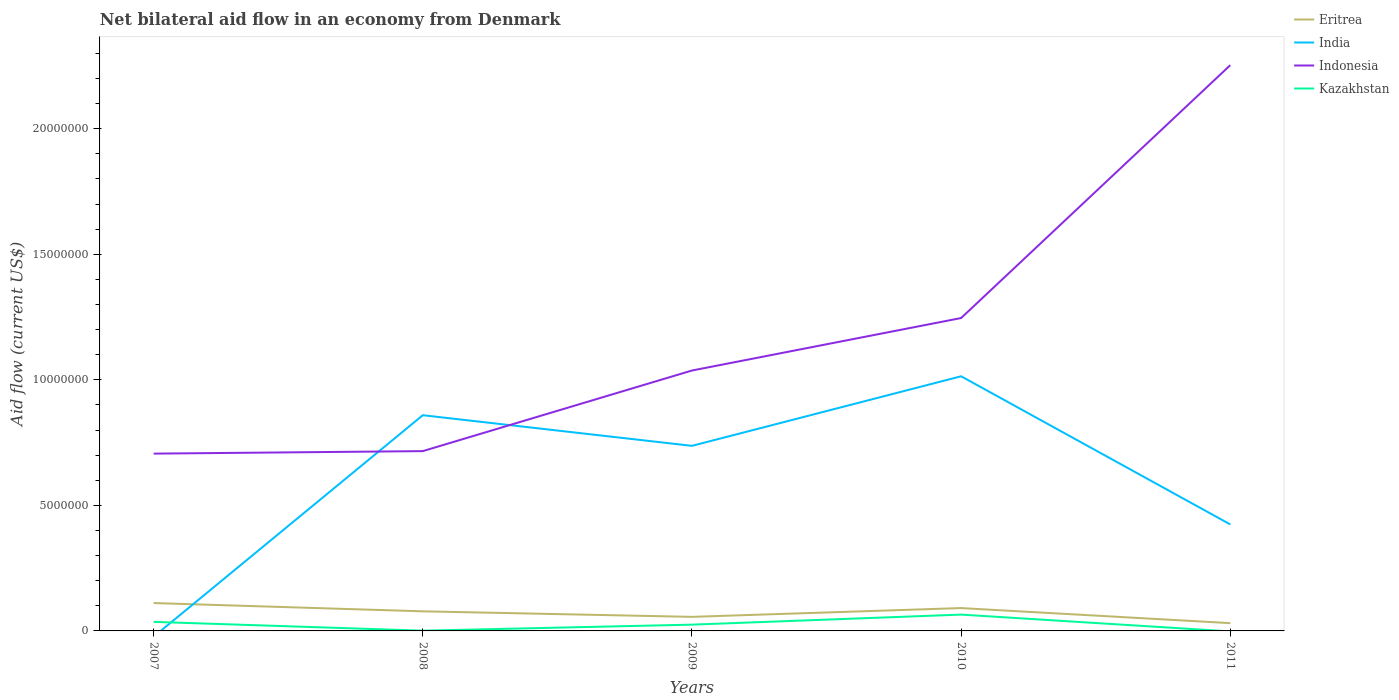How many different coloured lines are there?
Give a very brief answer. 4. Does the line corresponding to Kazakhstan intersect with the line corresponding to India?
Offer a very short reply. Yes. Is the number of lines equal to the number of legend labels?
Give a very brief answer. No. What is the total net bilateral aid flow in Indonesia in the graph?
Provide a succinct answer. -3.21e+06. What is the difference between the highest and the second highest net bilateral aid flow in India?
Provide a short and direct response. 1.01e+07. How many lines are there?
Your answer should be very brief. 4. How many years are there in the graph?
Make the answer very short. 5. Are the values on the major ticks of Y-axis written in scientific E-notation?
Your response must be concise. No. Does the graph contain any zero values?
Your response must be concise. Yes. How many legend labels are there?
Offer a terse response. 4. What is the title of the graph?
Give a very brief answer. Net bilateral aid flow in an economy from Denmark. What is the label or title of the X-axis?
Offer a terse response. Years. What is the Aid flow (current US$) in Eritrea in 2007?
Provide a succinct answer. 1.11e+06. What is the Aid flow (current US$) in Indonesia in 2007?
Provide a short and direct response. 7.06e+06. What is the Aid flow (current US$) in Eritrea in 2008?
Provide a succinct answer. 7.80e+05. What is the Aid flow (current US$) of India in 2008?
Your answer should be compact. 8.59e+06. What is the Aid flow (current US$) in Indonesia in 2008?
Provide a succinct answer. 7.16e+06. What is the Aid flow (current US$) of Kazakhstan in 2008?
Provide a succinct answer. 10000. What is the Aid flow (current US$) in Eritrea in 2009?
Provide a succinct answer. 5.60e+05. What is the Aid flow (current US$) of India in 2009?
Make the answer very short. 7.37e+06. What is the Aid flow (current US$) in Indonesia in 2009?
Offer a terse response. 1.04e+07. What is the Aid flow (current US$) of Kazakhstan in 2009?
Give a very brief answer. 2.50e+05. What is the Aid flow (current US$) of Eritrea in 2010?
Provide a succinct answer. 9.10e+05. What is the Aid flow (current US$) in India in 2010?
Your answer should be compact. 1.01e+07. What is the Aid flow (current US$) of Indonesia in 2010?
Keep it short and to the point. 1.25e+07. What is the Aid flow (current US$) in Kazakhstan in 2010?
Your answer should be very brief. 6.50e+05. What is the Aid flow (current US$) in Eritrea in 2011?
Provide a succinct answer. 3.10e+05. What is the Aid flow (current US$) in India in 2011?
Offer a very short reply. 4.24e+06. What is the Aid flow (current US$) in Indonesia in 2011?
Make the answer very short. 2.25e+07. Across all years, what is the maximum Aid flow (current US$) of Eritrea?
Provide a succinct answer. 1.11e+06. Across all years, what is the maximum Aid flow (current US$) of India?
Your answer should be very brief. 1.01e+07. Across all years, what is the maximum Aid flow (current US$) in Indonesia?
Your answer should be very brief. 2.25e+07. Across all years, what is the maximum Aid flow (current US$) of Kazakhstan?
Your answer should be very brief. 6.50e+05. Across all years, what is the minimum Aid flow (current US$) of Indonesia?
Offer a terse response. 7.06e+06. What is the total Aid flow (current US$) of Eritrea in the graph?
Keep it short and to the point. 3.67e+06. What is the total Aid flow (current US$) of India in the graph?
Make the answer very short. 3.03e+07. What is the total Aid flow (current US$) in Indonesia in the graph?
Offer a very short reply. 5.96e+07. What is the total Aid flow (current US$) in Kazakhstan in the graph?
Provide a short and direct response. 1.27e+06. What is the difference between the Aid flow (current US$) in Eritrea in 2007 and that in 2008?
Give a very brief answer. 3.30e+05. What is the difference between the Aid flow (current US$) in Indonesia in 2007 and that in 2008?
Make the answer very short. -1.00e+05. What is the difference between the Aid flow (current US$) of Kazakhstan in 2007 and that in 2008?
Keep it short and to the point. 3.50e+05. What is the difference between the Aid flow (current US$) in Eritrea in 2007 and that in 2009?
Make the answer very short. 5.50e+05. What is the difference between the Aid flow (current US$) of Indonesia in 2007 and that in 2009?
Offer a terse response. -3.31e+06. What is the difference between the Aid flow (current US$) of Kazakhstan in 2007 and that in 2009?
Make the answer very short. 1.10e+05. What is the difference between the Aid flow (current US$) in Indonesia in 2007 and that in 2010?
Give a very brief answer. -5.40e+06. What is the difference between the Aid flow (current US$) of Indonesia in 2007 and that in 2011?
Provide a short and direct response. -1.55e+07. What is the difference between the Aid flow (current US$) of India in 2008 and that in 2009?
Your answer should be compact. 1.22e+06. What is the difference between the Aid flow (current US$) of Indonesia in 2008 and that in 2009?
Ensure brevity in your answer.  -3.21e+06. What is the difference between the Aid flow (current US$) of Eritrea in 2008 and that in 2010?
Offer a terse response. -1.30e+05. What is the difference between the Aid flow (current US$) of India in 2008 and that in 2010?
Offer a terse response. -1.55e+06. What is the difference between the Aid flow (current US$) in Indonesia in 2008 and that in 2010?
Your answer should be very brief. -5.30e+06. What is the difference between the Aid flow (current US$) in Kazakhstan in 2008 and that in 2010?
Keep it short and to the point. -6.40e+05. What is the difference between the Aid flow (current US$) in India in 2008 and that in 2011?
Your answer should be very brief. 4.35e+06. What is the difference between the Aid flow (current US$) of Indonesia in 2008 and that in 2011?
Offer a very short reply. -1.54e+07. What is the difference between the Aid flow (current US$) of Eritrea in 2009 and that in 2010?
Give a very brief answer. -3.50e+05. What is the difference between the Aid flow (current US$) in India in 2009 and that in 2010?
Ensure brevity in your answer.  -2.77e+06. What is the difference between the Aid flow (current US$) of Indonesia in 2009 and that in 2010?
Give a very brief answer. -2.09e+06. What is the difference between the Aid flow (current US$) of Kazakhstan in 2009 and that in 2010?
Offer a terse response. -4.00e+05. What is the difference between the Aid flow (current US$) of Eritrea in 2009 and that in 2011?
Your response must be concise. 2.50e+05. What is the difference between the Aid flow (current US$) in India in 2009 and that in 2011?
Your answer should be compact. 3.13e+06. What is the difference between the Aid flow (current US$) in Indonesia in 2009 and that in 2011?
Your answer should be compact. -1.22e+07. What is the difference between the Aid flow (current US$) in Eritrea in 2010 and that in 2011?
Keep it short and to the point. 6.00e+05. What is the difference between the Aid flow (current US$) in India in 2010 and that in 2011?
Ensure brevity in your answer.  5.90e+06. What is the difference between the Aid flow (current US$) of Indonesia in 2010 and that in 2011?
Your response must be concise. -1.01e+07. What is the difference between the Aid flow (current US$) of Eritrea in 2007 and the Aid flow (current US$) of India in 2008?
Provide a short and direct response. -7.48e+06. What is the difference between the Aid flow (current US$) of Eritrea in 2007 and the Aid flow (current US$) of Indonesia in 2008?
Keep it short and to the point. -6.05e+06. What is the difference between the Aid flow (current US$) in Eritrea in 2007 and the Aid flow (current US$) in Kazakhstan in 2008?
Your answer should be compact. 1.10e+06. What is the difference between the Aid flow (current US$) of Indonesia in 2007 and the Aid flow (current US$) of Kazakhstan in 2008?
Your answer should be very brief. 7.05e+06. What is the difference between the Aid flow (current US$) in Eritrea in 2007 and the Aid flow (current US$) in India in 2009?
Keep it short and to the point. -6.26e+06. What is the difference between the Aid flow (current US$) in Eritrea in 2007 and the Aid flow (current US$) in Indonesia in 2009?
Your answer should be compact. -9.26e+06. What is the difference between the Aid flow (current US$) in Eritrea in 2007 and the Aid flow (current US$) in Kazakhstan in 2009?
Give a very brief answer. 8.60e+05. What is the difference between the Aid flow (current US$) of Indonesia in 2007 and the Aid flow (current US$) of Kazakhstan in 2009?
Give a very brief answer. 6.81e+06. What is the difference between the Aid flow (current US$) of Eritrea in 2007 and the Aid flow (current US$) of India in 2010?
Ensure brevity in your answer.  -9.03e+06. What is the difference between the Aid flow (current US$) in Eritrea in 2007 and the Aid flow (current US$) in Indonesia in 2010?
Make the answer very short. -1.14e+07. What is the difference between the Aid flow (current US$) in Indonesia in 2007 and the Aid flow (current US$) in Kazakhstan in 2010?
Your answer should be very brief. 6.41e+06. What is the difference between the Aid flow (current US$) in Eritrea in 2007 and the Aid flow (current US$) in India in 2011?
Keep it short and to the point. -3.13e+06. What is the difference between the Aid flow (current US$) of Eritrea in 2007 and the Aid flow (current US$) of Indonesia in 2011?
Ensure brevity in your answer.  -2.14e+07. What is the difference between the Aid flow (current US$) of Eritrea in 2008 and the Aid flow (current US$) of India in 2009?
Give a very brief answer. -6.59e+06. What is the difference between the Aid flow (current US$) of Eritrea in 2008 and the Aid flow (current US$) of Indonesia in 2009?
Keep it short and to the point. -9.59e+06. What is the difference between the Aid flow (current US$) in Eritrea in 2008 and the Aid flow (current US$) in Kazakhstan in 2009?
Make the answer very short. 5.30e+05. What is the difference between the Aid flow (current US$) in India in 2008 and the Aid flow (current US$) in Indonesia in 2009?
Offer a terse response. -1.78e+06. What is the difference between the Aid flow (current US$) of India in 2008 and the Aid flow (current US$) of Kazakhstan in 2009?
Offer a terse response. 8.34e+06. What is the difference between the Aid flow (current US$) in Indonesia in 2008 and the Aid flow (current US$) in Kazakhstan in 2009?
Make the answer very short. 6.91e+06. What is the difference between the Aid flow (current US$) of Eritrea in 2008 and the Aid flow (current US$) of India in 2010?
Offer a terse response. -9.36e+06. What is the difference between the Aid flow (current US$) of Eritrea in 2008 and the Aid flow (current US$) of Indonesia in 2010?
Ensure brevity in your answer.  -1.17e+07. What is the difference between the Aid flow (current US$) of India in 2008 and the Aid flow (current US$) of Indonesia in 2010?
Offer a very short reply. -3.87e+06. What is the difference between the Aid flow (current US$) of India in 2008 and the Aid flow (current US$) of Kazakhstan in 2010?
Keep it short and to the point. 7.94e+06. What is the difference between the Aid flow (current US$) in Indonesia in 2008 and the Aid flow (current US$) in Kazakhstan in 2010?
Give a very brief answer. 6.51e+06. What is the difference between the Aid flow (current US$) in Eritrea in 2008 and the Aid flow (current US$) in India in 2011?
Your answer should be very brief. -3.46e+06. What is the difference between the Aid flow (current US$) in Eritrea in 2008 and the Aid flow (current US$) in Indonesia in 2011?
Provide a short and direct response. -2.18e+07. What is the difference between the Aid flow (current US$) in India in 2008 and the Aid flow (current US$) in Indonesia in 2011?
Offer a very short reply. -1.39e+07. What is the difference between the Aid flow (current US$) of Eritrea in 2009 and the Aid flow (current US$) of India in 2010?
Your answer should be very brief. -9.58e+06. What is the difference between the Aid flow (current US$) of Eritrea in 2009 and the Aid flow (current US$) of Indonesia in 2010?
Ensure brevity in your answer.  -1.19e+07. What is the difference between the Aid flow (current US$) of India in 2009 and the Aid flow (current US$) of Indonesia in 2010?
Offer a terse response. -5.09e+06. What is the difference between the Aid flow (current US$) of India in 2009 and the Aid flow (current US$) of Kazakhstan in 2010?
Provide a succinct answer. 6.72e+06. What is the difference between the Aid flow (current US$) of Indonesia in 2009 and the Aid flow (current US$) of Kazakhstan in 2010?
Provide a short and direct response. 9.72e+06. What is the difference between the Aid flow (current US$) of Eritrea in 2009 and the Aid flow (current US$) of India in 2011?
Your answer should be very brief. -3.68e+06. What is the difference between the Aid flow (current US$) in Eritrea in 2009 and the Aid flow (current US$) in Indonesia in 2011?
Give a very brief answer. -2.20e+07. What is the difference between the Aid flow (current US$) of India in 2009 and the Aid flow (current US$) of Indonesia in 2011?
Ensure brevity in your answer.  -1.52e+07. What is the difference between the Aid flow (current US$) of Eritrea in 2010 and the Aid flow (current US$) of India in 2011?
Offer a terse response. -3.33e+06. What is the difference between the Aid flow (current US$) of Eritrea in 2010 and the Aid flow (current US$) of Indonesia in 2011?
Provide a succinct answer. -2.16e+07. What is the difference between the Aid flow (current US$) of India in 2010 and the Aid flow (current US$) of Indonesia in 2011?
Ensure brevity in your answer.  -1.24e+07. What is the average Aid flow (current US$) in Eritrea per year?
Keep it short and to the point. 7.34e+05. What is the average Aid flow (current US$) in India per year?
Provide a succinct answer. 6.07e+06. What is the average Aid flow (current US$) of Indonesia per year?
Offer a very short reply. 1.19e+07. What is the average Aid flow (current US$) of Kazakhstan per year?
Offer a terse response. 2.54e+05. In the year 2007, what is the difference between the Aid flow (current US$) in Eritrea and Aid flow (current US$) in Indonesia?
Ensure brevity in your answer.  -5.95e+06. In the year 2007, what is the difference between the Aid flow (current US$) in Eritrea and Aid flow (current US$) in Kazakhstan?
Provide a short and direct response. 7.50e+05. In the year 2007, what is the difference between the Aid flow (current US$) in Indonesia and Aid flow (current US$) in Kazakhstan?
Offer a terse response. 6.70e+06. In the year 2008, what is the difference between the Aid flow (current US$) of Eritrea and Aid flow (current US$) of India?
Offer a terse response. -7.81e+06. In the year 2008, what is the difference between the Aid flow (current US$) in Eritrea and Aid flow (current US$) in Indonesia?
Keep it short and to the point. -6.38e+06. In the year 2008, what is the difference between the Aid flow (current US$) in Eritrea and Aid flow (current US$) in Kazakhstan?
Provide a succinct answer. 7.70e+05. In the year 2008, what is the difference between the Aid flow (current US$) in India and Aid flow (current US$) in Indonesia?
Offer a terse response. 1.43e+06. In the year 2008, what is the difference between the Aid flow (current US$) of India and Aid flow (current US$) of Kazakhstan?
Offer a very short reply. 8.58e+06. In the year 2008, what is the difference between the Aid flow (current US$) of Indonesia and Aid flow (current US$) of Kazakhstan?
Make the answer very short. 7.15e+06. In the year 2009, what is the difference between the Aid flow (current US$) in Eritrea and Aid flow (current US$) in India?
Keep it short and to the point. -6.81e+06. In the year 2009, what is the difference between the Aid flow (current US$) in Eritrea and Aid flow (current US$) in Indonesia?
Provide a short and direct response. -9.81e+06. In the year 2009, what is the difference between the Aid flow (current US$) of India and Aid flow (current US$) of Indonesia?
Offer a very short reply. -3.00e+06. In the year 2009, what is the difference between the Aid flow (current US$) of India and Aid flow (current US$) of Kazakhstan?
Provide a succinct answer. 7.12e+06. In the year 2009, what is the difference between the Aid flow (current US$) of Indonesia and Aid flow (current US$) of Kazakhstan?
Offer a terse response. 1.01e+07. In the year 2010, what is the difference between the Aid flow (current US$) in Eritrea and Aid flow (current US$) in India?
Ensure brevity in your answer.  -9.23e+06. In the year 2010, what is the difference between the Aid flow (current US$) of Eritrea and Aid flow (current US$) of Indonesia?
Provide a succinct answer. -1.16e+07. In the year 2010, what is the difference between the Aid flow (current US$) of India and Aid flow (current US$) of Indonesia?
Offer a terse response. -2.32e+06. In the year 2010, what is the difference between the Aid flow (current US$) in India and Aid flow (current US$) in Kazakhstan?
Your answer should be compact. 9.49e+06. In the year 2010, what is the difference between the Aid flow (current US$) in Indonesia and Aid flow (current US$) in Kazakhstan?
Offer a terse response. 1.18e+07. In the year 2011, what is the difference between the Aid flow (current US$) in Eritrea and Aid flow (current US$) in India?
Provide a succinct answer. -3.93e+06. In the year 2011, what is the difference between the Aid flow (current US$) of Eritrea and Aid flow (current US$) of Indonesia?
Ensure brevity in your answer.  -2.22e+07. In the year 2011, what is the difference between the Aid flow (current US$) of India and Aid flow (current US$) of Indonesia?
Offer a very short reply. -1.83e+07. What is the ratio of the Aid flow (current US$) in Eritrea in 2007 to that in 2008?
Ensure brevity in your answer.  1.42. What is the ratio of the Aid flow (current US$) of Eritrea in 2007 to that in 2009?
Offer a very short reply. 1.98. What is the ratio of the Aid flow (current US$) in Indonesia in 2007 to that in 2009?
Make the answer very short. 0.68. What is the ratio of the Aid flow (current US$) in Kazakhstan in 2007 to that in 2009?
Provide a succinct answer. 1.44. What is the ratio of the Aid flow (current US$) of Eritrea in 2007 to that in 2010?
Ensure brevity in your answer.  1.22. What is the ratio of the Aid flow (current US$) of Indonesia in 2007 to that in 2010?
Give a very brief answer. 0.57. What is the ratio of the Aid flow (current US$) of Kazakhstan in 2007 to that in 2010?
Your response must be concise. 0.55. What is the ratio of the Aid flow (current US$) of Eritrea in 2007 to that in 2011?
Ensure brevity in your answer.  3.58. What is the ratio of the Aid flow (current US$) of Indonesia in 2007 to that in 2011?
Provide a succinct answer. 0.31. What is the ratio of the Aid flow (current US$) in Eritrea in 2008 to that in 2009?
Keep it short and to the point. 1.39. What is the ratio of the Aid flow (current US$) of India in 2008 to that in 2009?
Provide a short and direct response. 1.17. What is the ratio of the Aid flow (current US$) of Indonesia in 2008 to that in 2009?
Your answer should be very brief. 0.69. What is the ratio of the Aid flow (current US$) of India in 2008 to that in 2010?
Keep it short and to the point. 0.85. What is the ratio of the Aid flow (current US$) in Indonesia in 2008 to that in 2010?
Make the answer very short. 0.57. What is the ratio of the Aid flow (current US$) of Kazakhstan in 2008 to that in 2010?
Give a very brief answer. 0.02. What is the ratio of the Aid flow (current US$) of Eritrea in 2008 to that in 2011?
Your answer should be compact. 2.52. What is the ratio of the Aid flow (current US$) in India in 2008 to that in 2011?
Give a very brief answer. 2.03. What is the ratio of the Aid flow (current US$) of Indonesia in 2008 to that in 2011?
Ensure brevity in your answer.  0.32. What is the ratio of the Aid flow (current US$) of Eritrea in 2009 to that in 2010?
Make the answer very short. 0.62. What is the ratio of the Aid flow (current US$) in India in 2009 to that in 2010?
Keep it short and to the point. 0.73. What is the ratio of the Aid flow (current US$) in Indonesia in 2009 to that in 2010?
Your answer should be very brief. 0.83. What is the ratio of the Aid flow (current US$) in Kazakhstan in 2009 to that in 2010?
Provide a short and direct response. 0.38. What is the ratio of the Aid flow (current US$) in Eritrea in 2009 to that in 2011?
Make the answer very short. 1.81. What is the ratio of the Aid flow (current US$) in India in 2009 to that in 2011?
Your answer should be compact. 1.74. What is the ratio of the Aid flow (current US$) of Indonesia in 2009 to that in 2011?
Give a very brief answer. 0.46. What is the ratio of the Aid flow (current US$) of Eritrea in 2010 to that in 2011?
Offer a very short reply. 2.94. What is the ratio of the Aid flow (current US$) of India in 2010 to that in 2011?
Make the answer very short. 2.39. What is the ratio of the Aid flow (current US$) of Indonesia in 2010 to that in 2011?
Give a very brief answer. 0.55. What is the difference between the highest and the second highest Aid flow (current US$) of Eritrea?
Your answer should be compact. 2.00e+05. What is the difference between the highest and the second highest Aid flow (current US$) in India?
Provide a short and direct response. 1.55e+06. What is the difference between the highest and the second highest Aid flow (current US$) in Indonesia?
Keep it short and to the point. 1.01e+07. What is the difference between the highest and the lowest Aid flow (current US$) of Eritrea?
Make the answer very short. 8.00e+05. What is the difference between the highest and the lowest Aid flow (current US$) of India?
Offer a very short reply. 1.01e+07. What is the difference between the highest and the lowest Aid flow (current US$) of Indonesia?
Provide a succinct answer. 1.55e+07. What is the difference between the highest and the lowest Aid flow (current US$) of Kazakhstan?
Provide a succinct answer. 6.50e+05. 